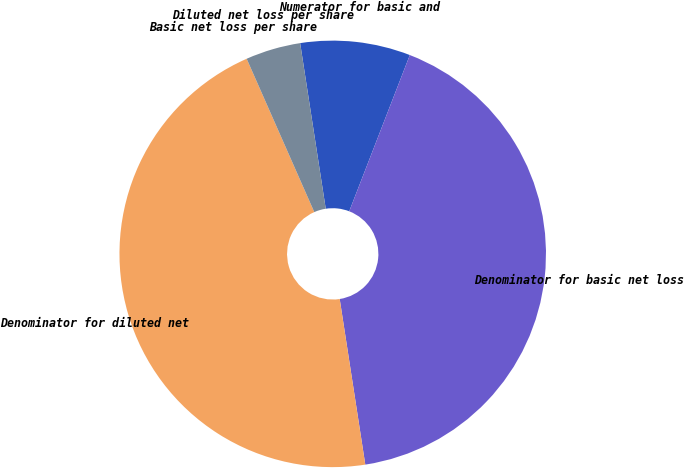Convert chart. <chart><loc_0><loc_0><loc_500><loc_500><pie_chart><fcel>Numerator for basic and<fcel>Denominator for basic net loss<fcel>Denominator for diluted net<fcel>Basic net loss per share<fcel>Diluted net loss per share<nl><fcel>8.33%<fcel>41.67%<fcel>45.83%<fcel>0.0%<fcel>4.17%<nl></chart> 